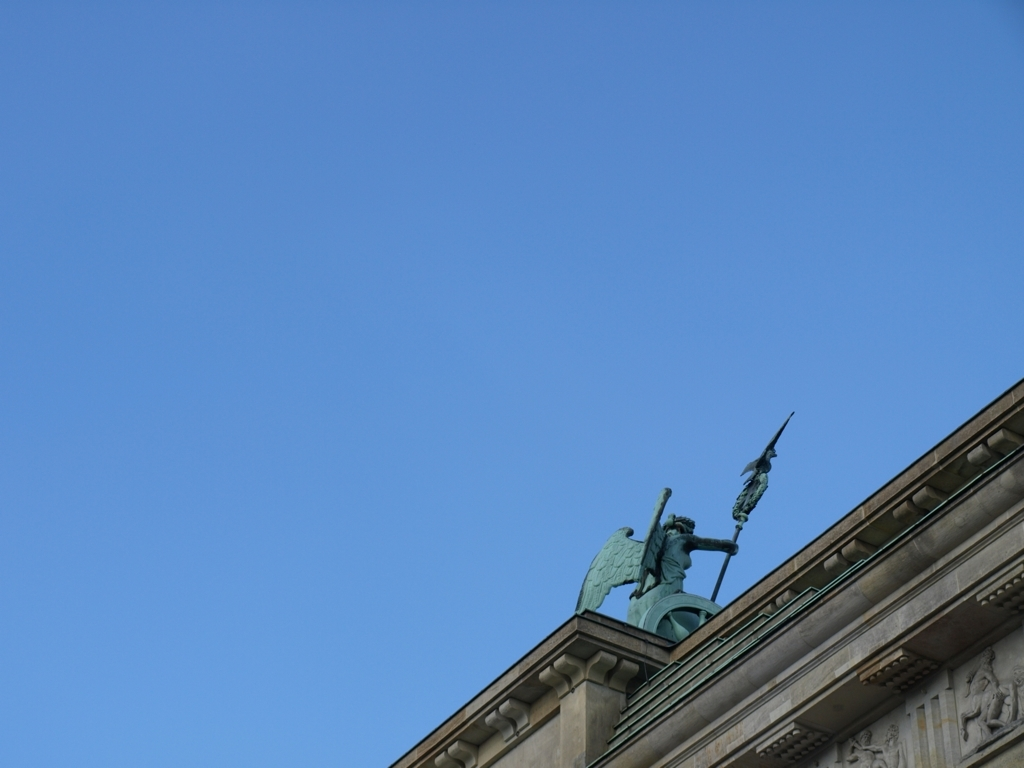What does the subject of this image symbolize, and is there historical significance? The statue in the image conveys a sense of guardianship or victory, often associated with historical or mythological figures. The warrior-like pose suggests it might commemorate an important figure or event. Its historical significance would depend on its location and whom it represents, which can add depth to its interpretation. 